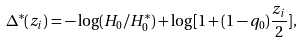<formula> <loc_0><loc_0><loc_500><loc_500>\Delta ^ { * } ( z _ { i } ) = - \log ( H _ { 0 } / H _ { 0 } ^ { * } ) + \log [ 1 + ( 1 - q _ { 0 } ) \frac { z _ { i } } { 2 } ] ,</formula> 